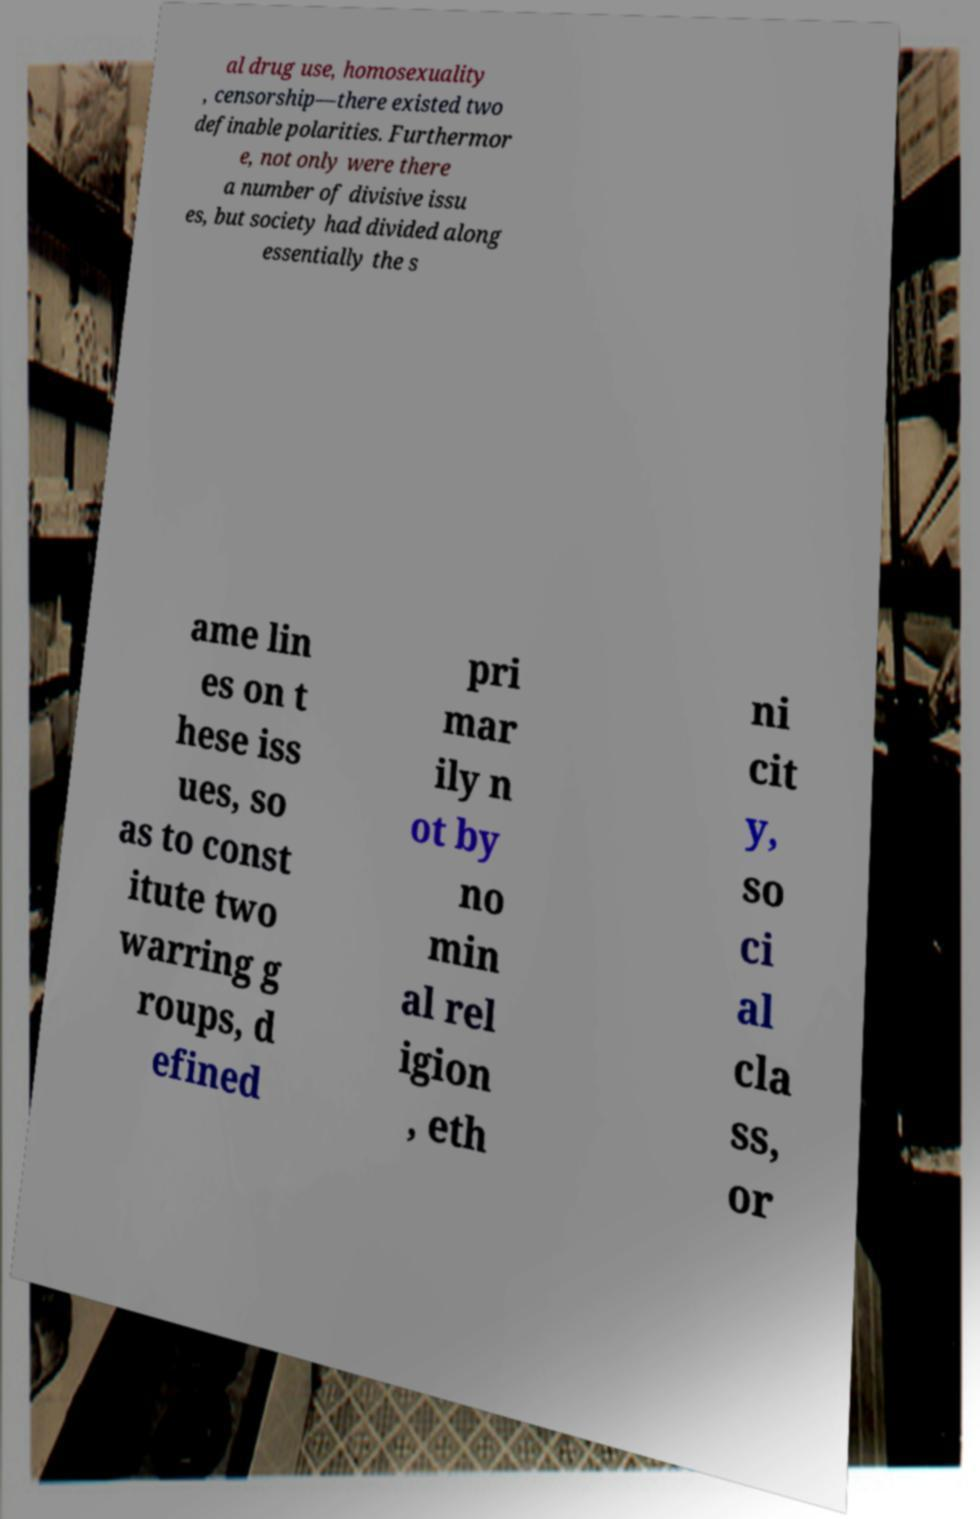There's text embedded in this image that I need extracted. Can you transcribe it verbatim? al drug use, homosexuality , censorship—there existed two definable polarities. Furthermor e, not only were there a number of divisive issu es, but society had divided along essentially the s ame lin es on t hese iss ues, so as to const itute two warring g roups, d efined pri mar ily n ot by no min al rel igion , eth ni cit y, so ci al cla ss, or 